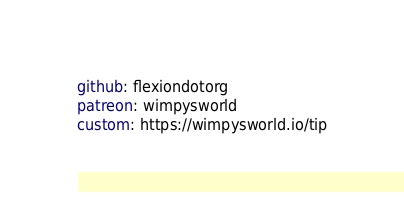<code> <loc_0><loc_0><loc_500><loc_500><_YAML_>github: flexiondotorg
patreon: wimpysworld
custom: https://wimpysworld.io/tip</code> 